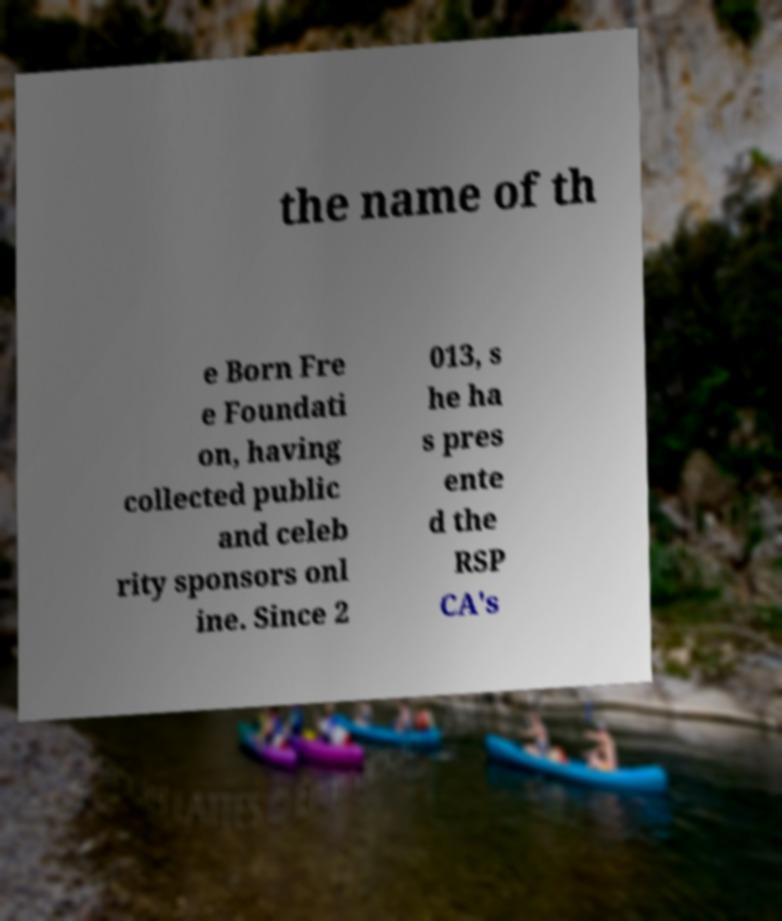Could you extract and type out the text from this image? the name of th e Born Fre e Foundati on, having collected public and celeb rity sponsors onl ine. Since 2 013, s he ha s pres ente d the RSP CA's 